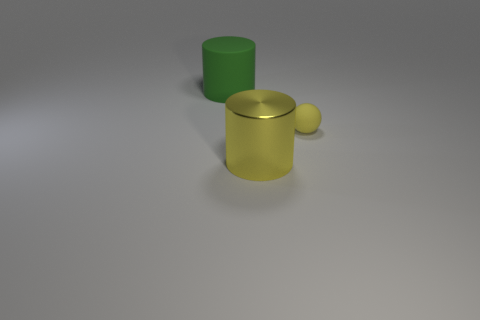Add 1 metal cylinders. How many objects exist? 4 Subtract all balls. How many objects are left? 2 Subtract all shiny objects. Subtract all brown balls. How many objects are left? 2 Add 2 tiny yellow matte things. How many tiny yellow matte things are left? 3 Add 3 small green balls. How many small green balls exist? 3 Subtract 0 purple blocks. How many objects are left? 3 